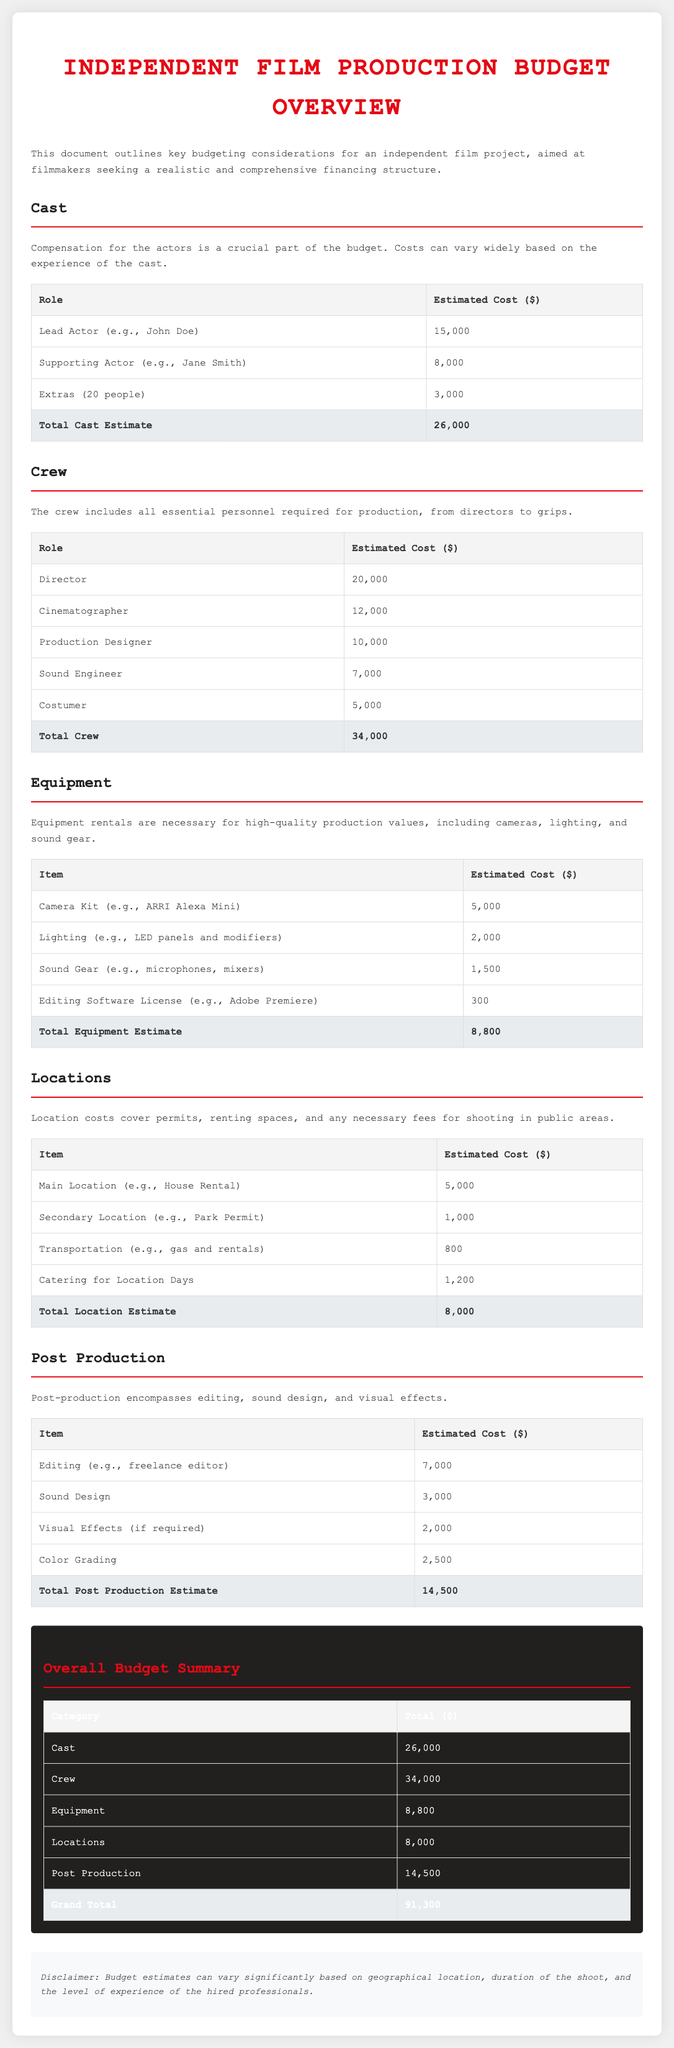what is the estimated cost for the lead actor? The document specifies the estimated cost for the lead actor as $15,000.
Answer: $15,000 what is the total estimated cost for the crew? The total estimated cost for the crew is provided as $34,000 in the budget summary.
Answer: $34,000 how much is budgeted for sound gear? The document lists the estimated cost for sound gear as $1,500.
Answer: $1,500 what is the total budget for post-production? The total budget for post-production is specified as $14,500.
Answer: $14,500 what is the grand total of the overall budget? The grand total of the overall budget is calculated to be $91,300.
Answer: $91,300 how much is allocated for location transportation? The estimated cost for transportation is quoted as $800 in the locations section.
Answer: $800 which category has the highest estimated cost? The category with the highest estimated cost is the crew, with an estimate of $34,000.
Answer: Crew how many extras are included in the cast budget? The document mentions that there are 20 extras included in the cast budget.
Answer: 20 what is the cost for a cinematographer? The estimated cost for a cinematographer is stated as $12,000.
Answer: $12,000 what item is the editing software license for? The editing software license mentioned is for Adobe Premiere, according to the document.
Answer: Adobe Premiere 